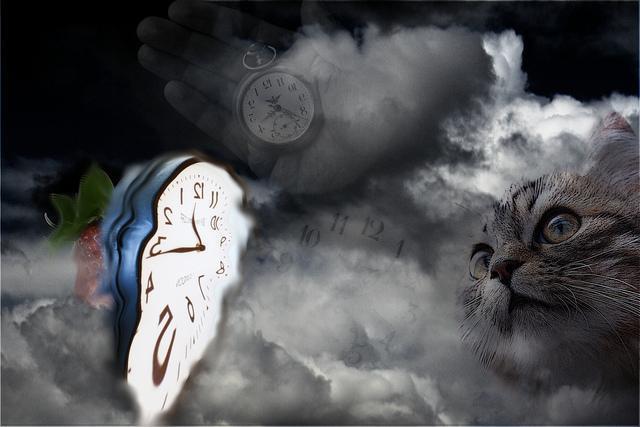How many clocks are visible?
Give a very brief answer. 2. 